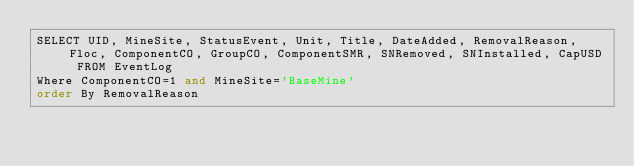Convert code to text. <code><loc_0><loc_0><loc_500><loc_500><_SQL_>SELECT UID, MineSite, StatusEvent, Unit, Title, DateAdded, RemovalReason, Floc, ComponentCO, GroupCO, ComponentSMR, SNRemoved, SNInstalled, CapUSD FROM EventLog
Where ComponentCO=1 and MineSite='BaseMine'
order By RemovalReason</code> 